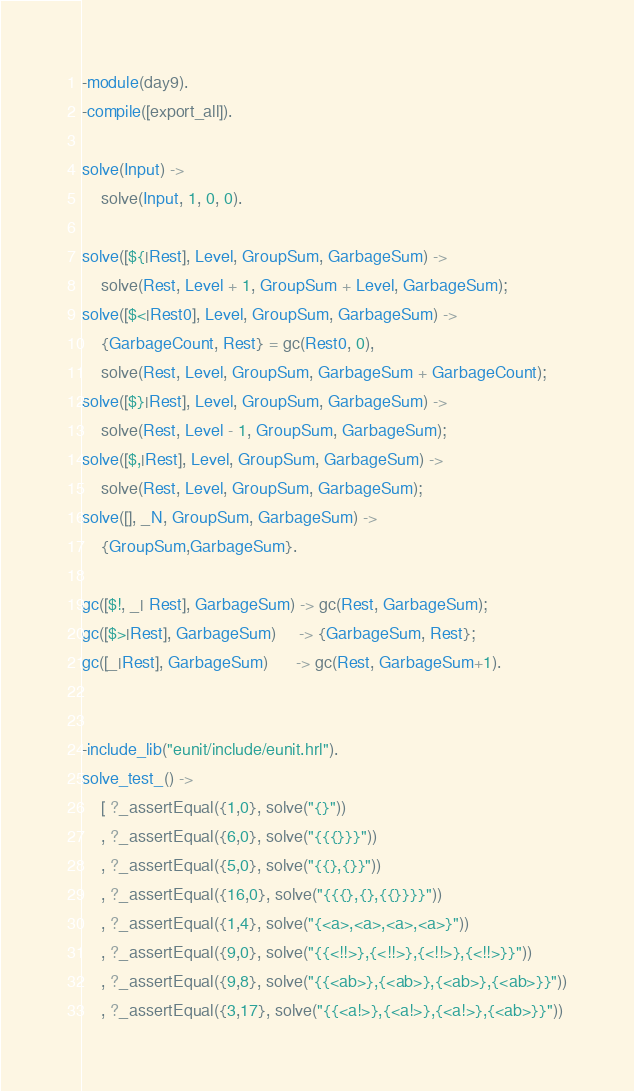<code> <loc_0><loc_0><loc_500><loc_500><_Erlang_>-module(day9).
-compile([export_all]).

solve(Input) ->
    solve(Input, 1, 0, 0).

solve([${|Rest], Level, GroupSum, GarbageSum) ->
    solve(Rest, Level + 1, GroupSum + Level, GarbageSum);
solve([$<|Rest0], Level, GroupSum, GarbageSum) ->
    {GarbageCount, Rest} = gc(Rest0, 0),
    solve(Rest, Level, GroupSum, GarbageSum + GarbageCount);
solve([$}|Rest], Level, GroupSum, GarbageSum) ->
    solve(Rest, Level - 1, GroupSum, GarbageSum);
solve([$,|Rest], Level, GroupSum, GarbageSum) ->
    solve(Rest, Level, GroupSum, GarbageSum);
solve([], _N, GroupSum, GarbageSum) ->
    {GroupSum,GarbageSum}.

gc([$!, _| Rest], GarbageSum) -> gc(Rest, GarbageSum);
gc([$>|Rest], GarbageSum)     -> {GarbageSum, Rest};
gc([_|Rest], GarbageSum)      -> gc(Rest, GarbageSum+1).


-include_lib("eunit/include/eunit.hrl").
solve_test_() ->
    [ ?_assertEqual({1,0}, solve("{}"))
    , ?_assertEqual({6,0}, solve("{{{}}}"))
    , ?_assertEqual({5,0}, solve("{{},{}}"))
    , ?_assertEqual({16,0}, solve("{{{},{},{{}}}}"))
    , ?_assertEqual({1,4}, solve("{<a>,<a>,<a>,<a>}"))
    , ?_assertEqual({9,0}, solve("{{<!!>},{<!!>},{<!!>},{<!!>}}"))
    , ?_assertEqual({9,8}, solve("{{<ab>},{<ab>},{<ab>},{<ab>}}"))
    , ?_assertEqual({3,17}, solve("{{<a!>},{<a!>},{<a!>},{<ab>}}"))</code> 